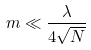<formula> <loc_0><loc_0><loc_500><loc_500>m \ll \frac { \lambda } { 4 \sqrt { N } }</formula> 